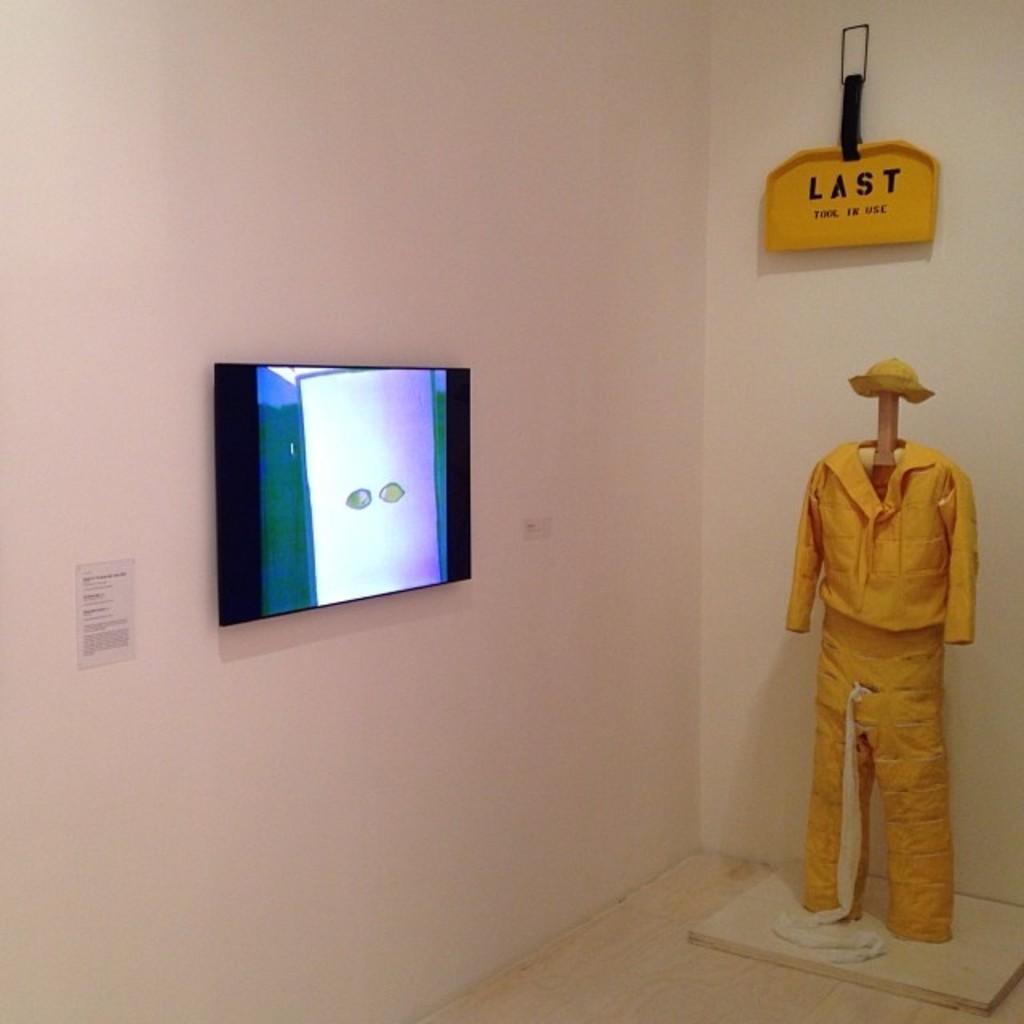In one or two sentences, can you explain what this image depicts? In this image there is a television on the wall. Beside the television there is a small paper sticked on the wall. To the right there is a dress. Above to it there is a board. There is text on the board. In the background there is a wall. 